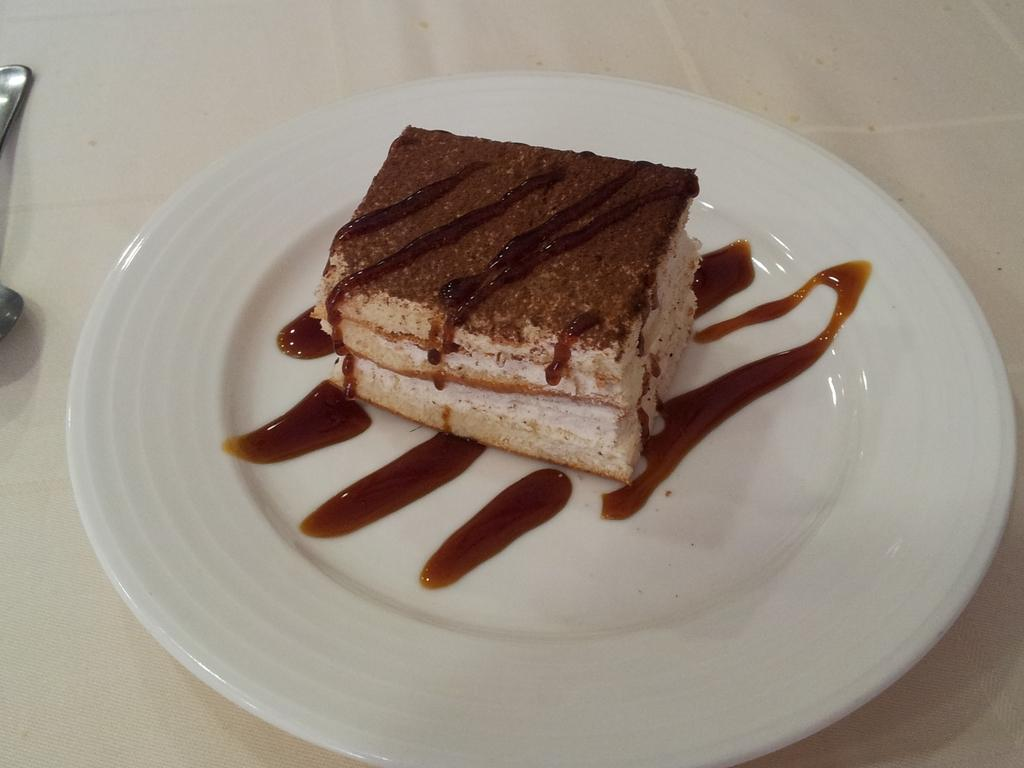What is present on the plate in the image? There is food on the plate in the image. What utensil is visible in the image? There is a spoon in the image. Where are the plate, food, and spoon located? The plate, food, and spoon are on a platform. What type of muscle can be seen flexing on the plate in the image? There is no muscle present on the plate in the image; it contains food. 